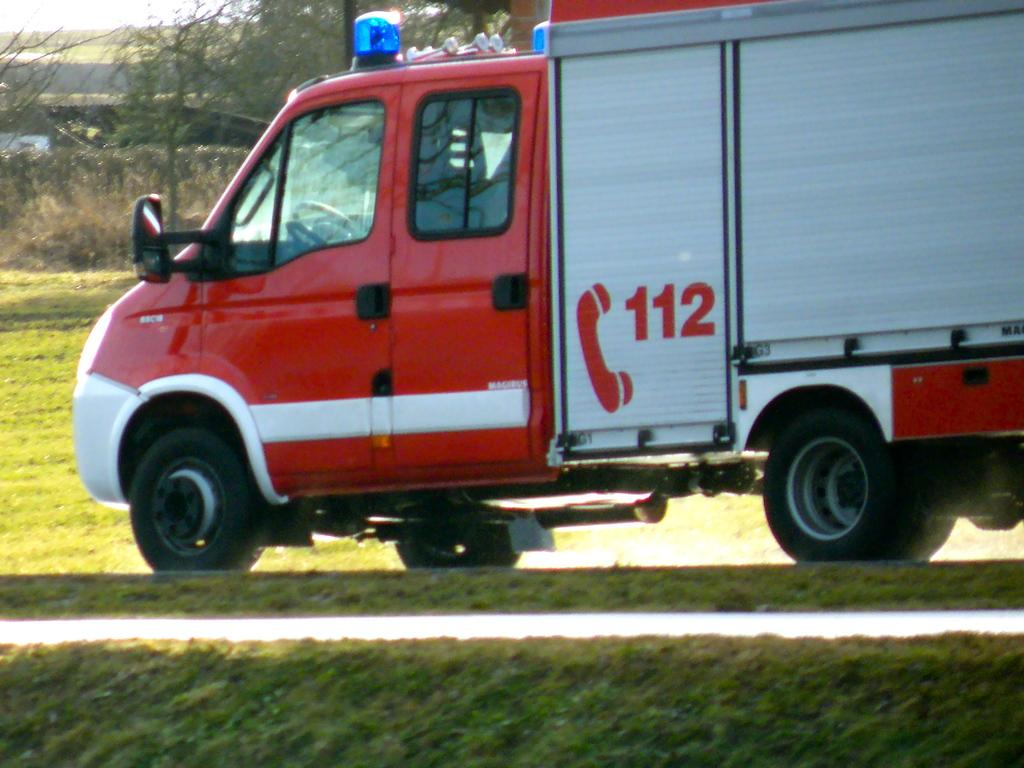What is the main subject in the center of the image? There is a vehicle in the center of the image. What can be seen in the background of the image? There are trees and houses in the background of the image. What type of vegetation is visible at the bottom of the image? There is grass at the bottom of the image. What type of path is visible at the bottom of the image? There is a walkway at the bottom of the image. What type of ring can be seen on the vehicle in the image? There is no ring visible on the vehicle in the image. What type of plant is growing on the walkway in the image? There are no plants growing on the walkway in the image. 